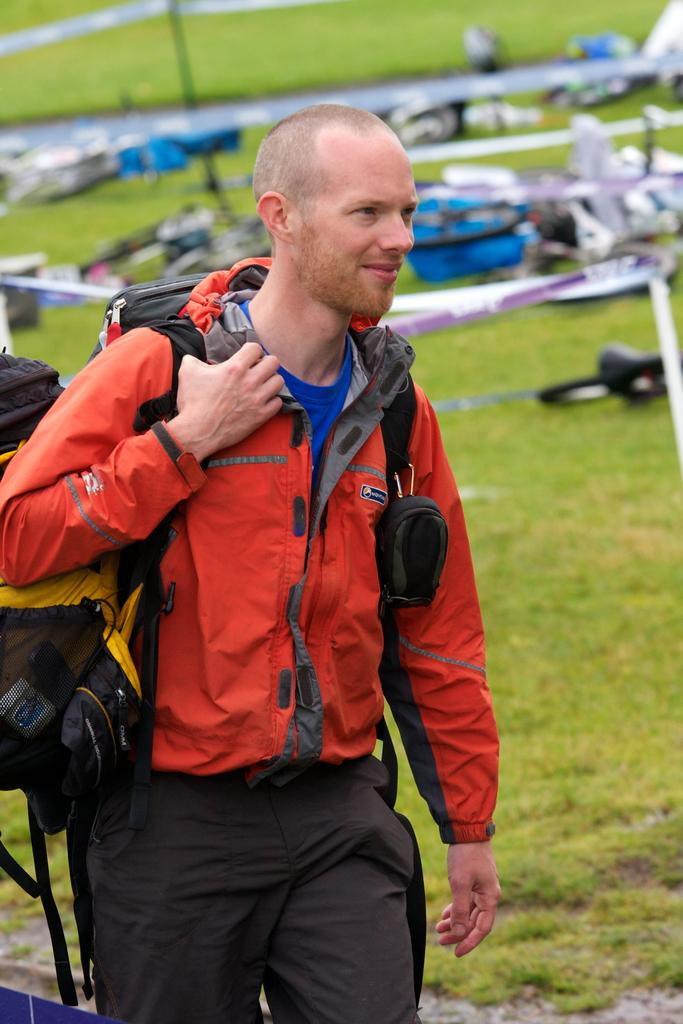What is the main subject in the foreground of the picture? There is a person in the foreground of the picture. What is the person wearing in the picture? The person is wearing an orange jacket. What else is the person carrying in the picture? The person is wearing a backpack. What can be seen in the background of the picture? There are bicycles, ribbons, and grass in the background of the picture. What type of shirt is the person's partner wearing in the picture? There is no partner present in the picture, so it is not possible to determine what type of shirt they might be wearing. 